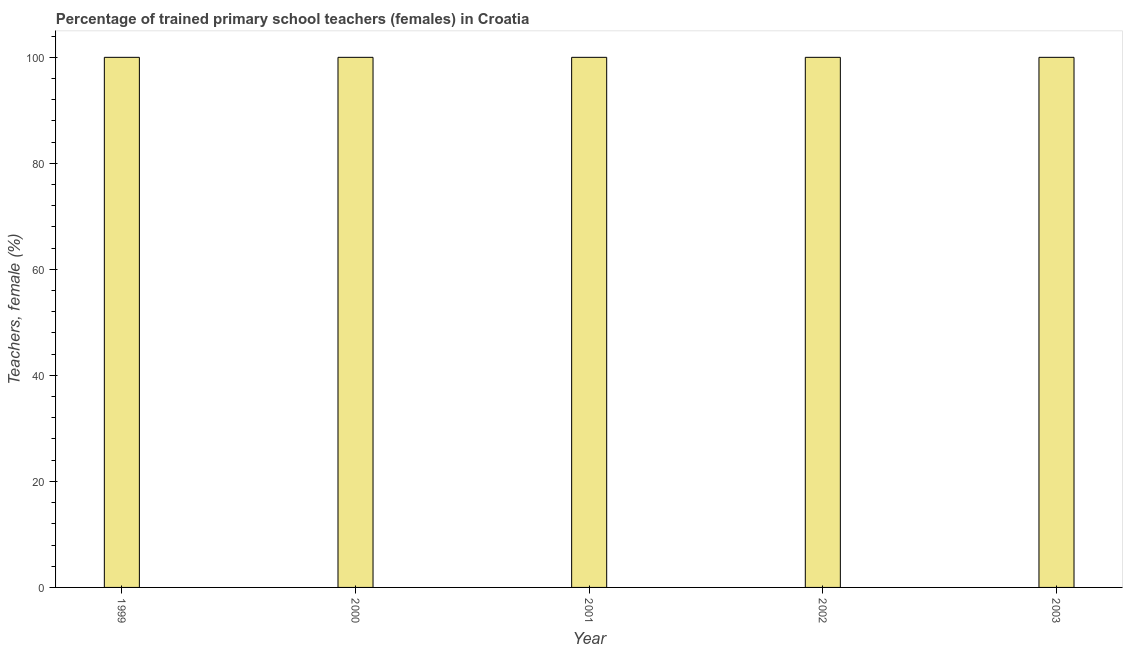Does the graph contain any zero values?
Provide a succinct answer. No. What is the title of the graph?
Provide a succinct answer. Percentage of trained primary school teachers (females) in Croatia. What is the label or title of the Y-axis?
Offer a very short reply. Teachers, female (%). In which year was the percentage of trained female teachers maximum?
Your answer should be very brief. 1999. In which year was the percentage of trained female teachers minimum?
Offer a terse response. 1999. In how many years, is the percentage of trained female teachers greater than 52 %?
Provide a short and direct response. 5. Is the percentage of trained female teachers in 2000 less than that in 2003?
Make the answer very short. No. In how many years, is the percentage of trained female teachers greater than the average percentage of trained female teachers taken over all years?
Give a very brief answer. 0. How many years are there in the graph?
Make the answer very short. 5. What is the Teachers, female (%) of 2000?
Your answer should be compact. 100. What is the Teachers, female (%) of 2003?
Your answer should be very brief. 100. What is the difference between the Teachers, female (%) in 1999 and 2000?
Your response must be concise. 0. What is the difference between the Teachers, female (%) in 2000 and 2001?
Offer a terse response. 0. What is the difference between the Teachers, female (%) in 2000 and 2003?
Your answer should be very brief. 0. What is the difference between the Teachers, female (%) in 2001 and 2002?
Provide a short and direct response. 0. What is the difference between the Teachers, female (%) in 2002 and 2003?
Make the answer very short. 0. What is the ratio of the Teachers, female (%) in 1999 to that in 2001?
Give a very brief answer. 1. What is the ratio of the Teachers, female (%) in 1999 to that in 2003?
Provide a succinct answer. 1. What is the ratio of the Teachers, female (%) in 2000 to that in 2002?
Your answer should be compact. 1. What is the ratio of the Teachers, female (%) in 2001 to that in 2002?
Keep it short and to the point. 1. What is the ratio of the Teachers, female (%) in 2001 to that in 2003?
Provide a short and direct response. 1. What is the ratio of the Teachers, female (%) in 2002 to that in 2003?
Make the answer very short. 1. 